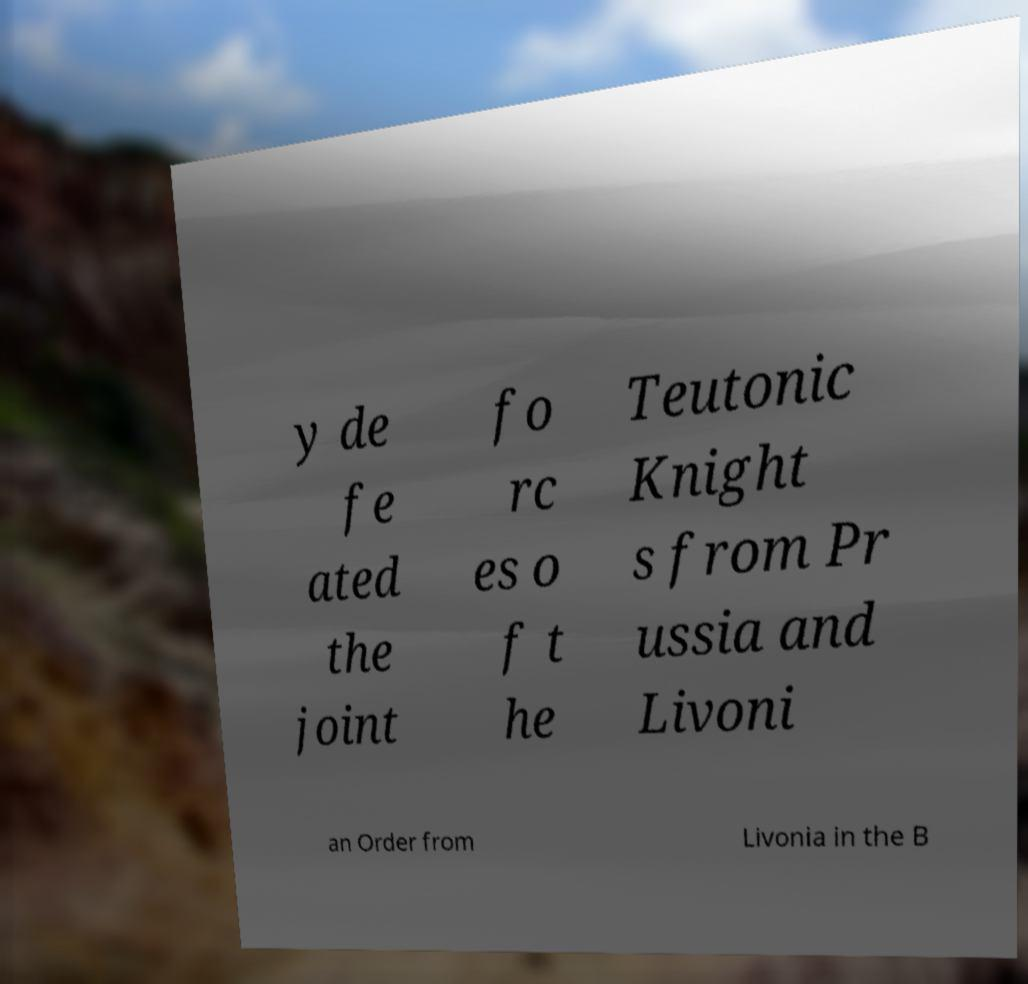Can you read and provide the text displayed in the image?This photo seems to have some interesting text. Can you extract and type it out for me? y de fe ated the joint fo rc es o f t he Teutonic Knight s from Pr ussia and Livoni an Order from Livonia in the B 